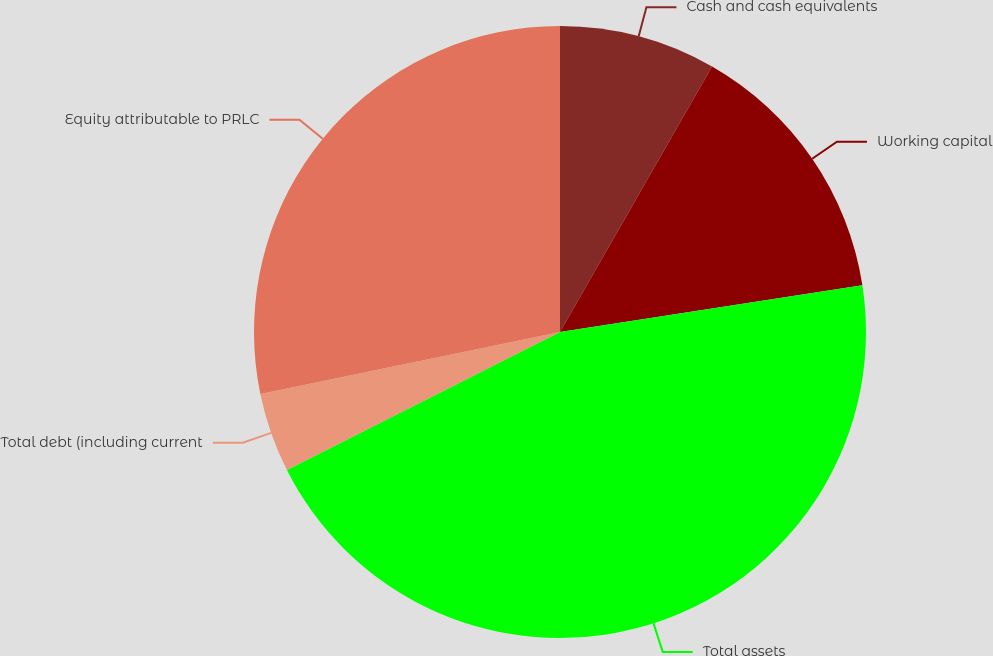<chart> <loc_0><loc_0><loc_500><loc_500><pie_chart><fcel>Cash and cash equivalents<fcel>Working capital<fcel>Total assets<fcel>Total debt (including current<fcel>Equity attributable to PRLC<nl><fcel>8.28%<fcel>14.28%<fcel>45.0%<fcel>4.2%<fcel>28.25%<nl></chart> 